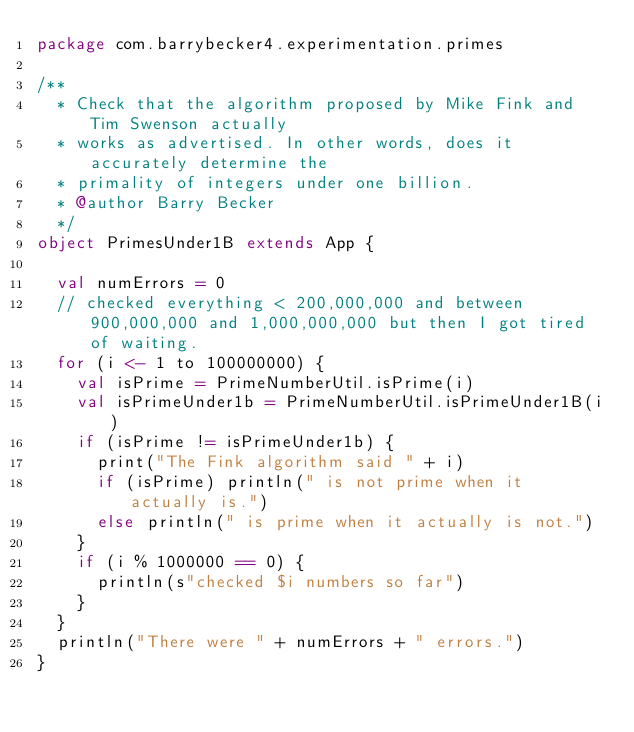Convert code to text. <code><loc_0><loc_0><loc_500><loc_500><_Scala_>package com.barrybecker4.experimentation.primes

/**
  * Check that the algorithm proposed by Mike Fink and Tim Swenson actually
  * works as advertised. In other words, does it accurately determine the
  * primality of integers under one billion.
  * @author Barry Becker
  */
object PrimesUnder1B extends App {

  val numErrors = 0
  // checked everything < 200,000,000 and between 900,000,000 and 1,000,000,000 but then I got tired of waiting.
  for (i <- 1 to 100000000) {
    val isPrime = PrimeNumberUtil.isPrime(i)
    val isPrimeUnder1b = PrimeNumberUtil.isPrimeUnder1B(i)
    if (isPrime != isPrimeUnder1b) {
      print("The Fink algorithm said " + i)
      if (isPrime) println(" is not prime when it actually is.")
      else println(" is prime when it actually is not.")
    }
    if (i % 1000000 == 0) {
      println(s"checked $i numbers so far")
    }
  }
  println("There were " + numErrors + " errors.")
}
</code> 